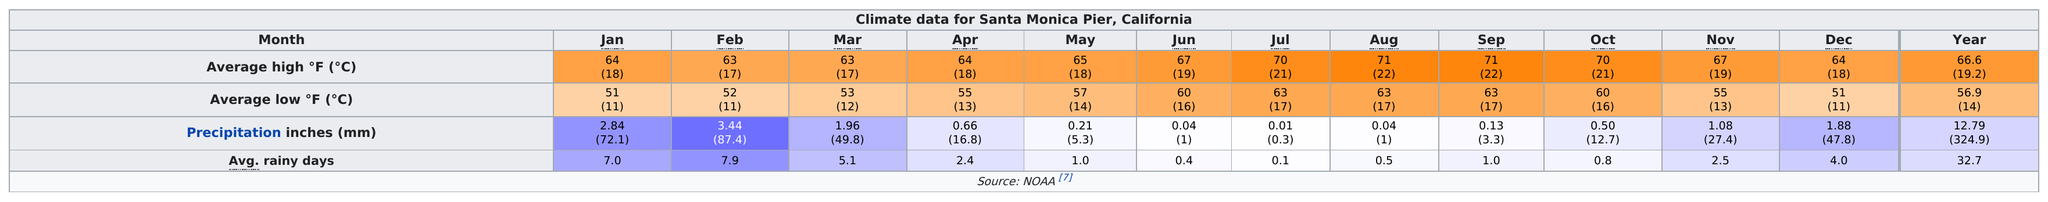Give some essential details in this illustration. March was the month that had an average low of 53 degrees and an average high of 63 degrees. For how many months did the average number of rainy days remain the same? The answer is 2 months. January had the least average rainy days when compared to February. 